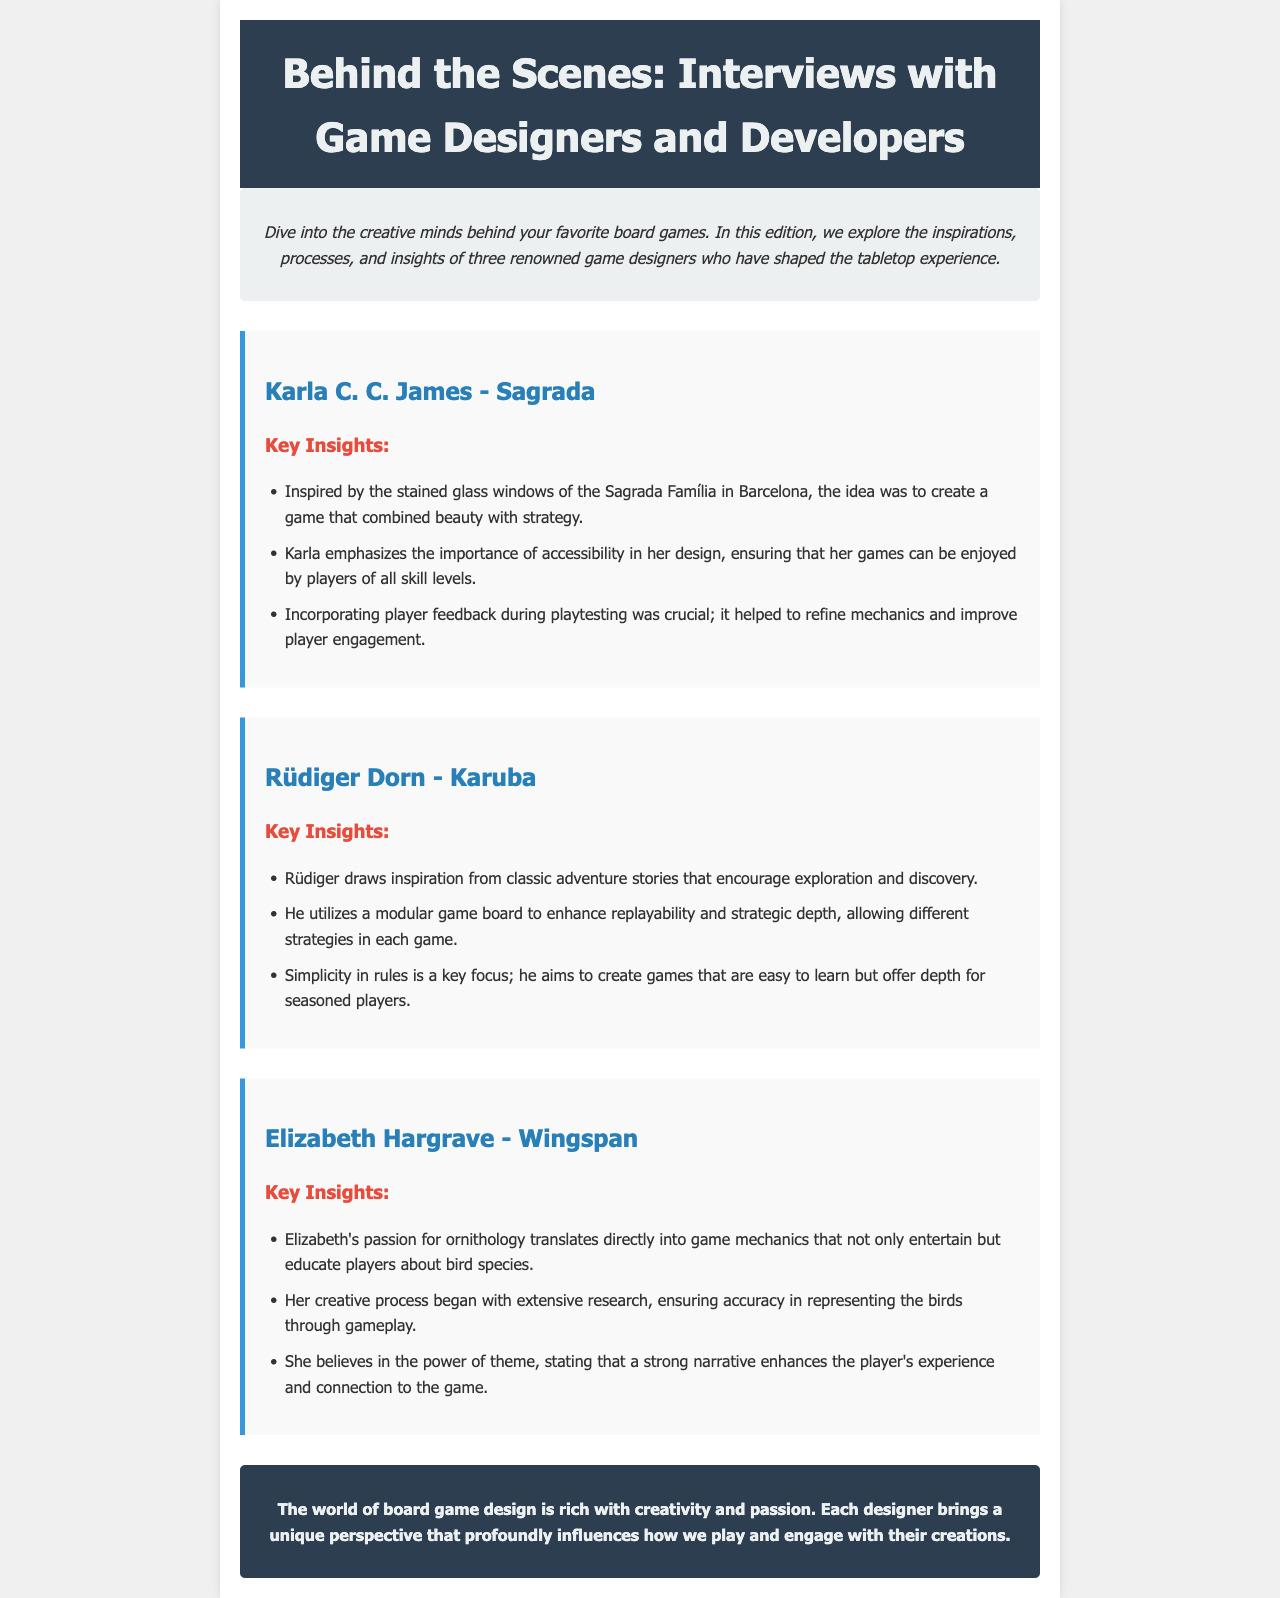What is the title of the newsletter? The title of the newsletter is prominently displayed in the header section of the document.
Answer: Behind the Scenes: Interviews with Game Designers and Developers Who designed the game Sagrada? This information is found in the first interview section of the document.
Answer: Karla C. C. James What is a key inspiration for the game Karuba? This detail is provided in the interview with Rüdiger Dorn, highlighting the source of inspiration for his design.
Answer: Classic adventure stories How does Elizabeth Hargrave’s game Wingspan educate players? This insight is based on the key themes discussed in her interview in relation to the game's features.
Answer: Ornithology What does Karla emphasize about accessibility in her designs? This focus is a critical point discussed in Karla C. C. James's interview section.
Answer: Importance of accessibility How does Rüdiger Dorn enhance the replayability of Karuba? This information is derived from the insights he shares about his design philosophy.
Answer: Modular game board What is the main theme of the newsletter? The overall theme can be inferred from the introductory paragraph outlining the newsletter's purpose.
Answer: Creative minds behind board games What narrative aspect does Elizabeth Hargrave believe enhances gameplay? This belief is articulated in the insights shared about her creative approach.
Answer: Strong narrative 